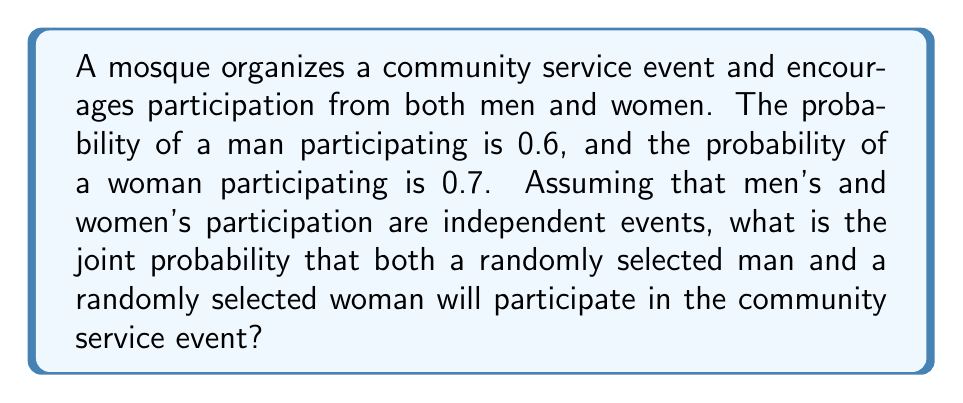Could you help me with this problem? Let's approach this step-by-step:

1) Let M be the event that a man participates, and W be the event that a woman participates.

2) We are given:
   P(M) = 0.6
   P(W) = 0.7

3) We need to find P(M and W), which is the joint probability of both events occurring.

4) Since the events are independent, we can use the multiplication rule of probability:

   P(M and W) = P(M) × P(W)

5) Substituting the given probabilities:

   P(M and W) = 0.6 × 0.7

6) Calculate:
   
   P(M and W) = 0.42

Therefore, the joint probability that both a randomly selected man and a randomly selected woman will participate in the community service event is 0.42 or 42%.
Answer: 0.42 